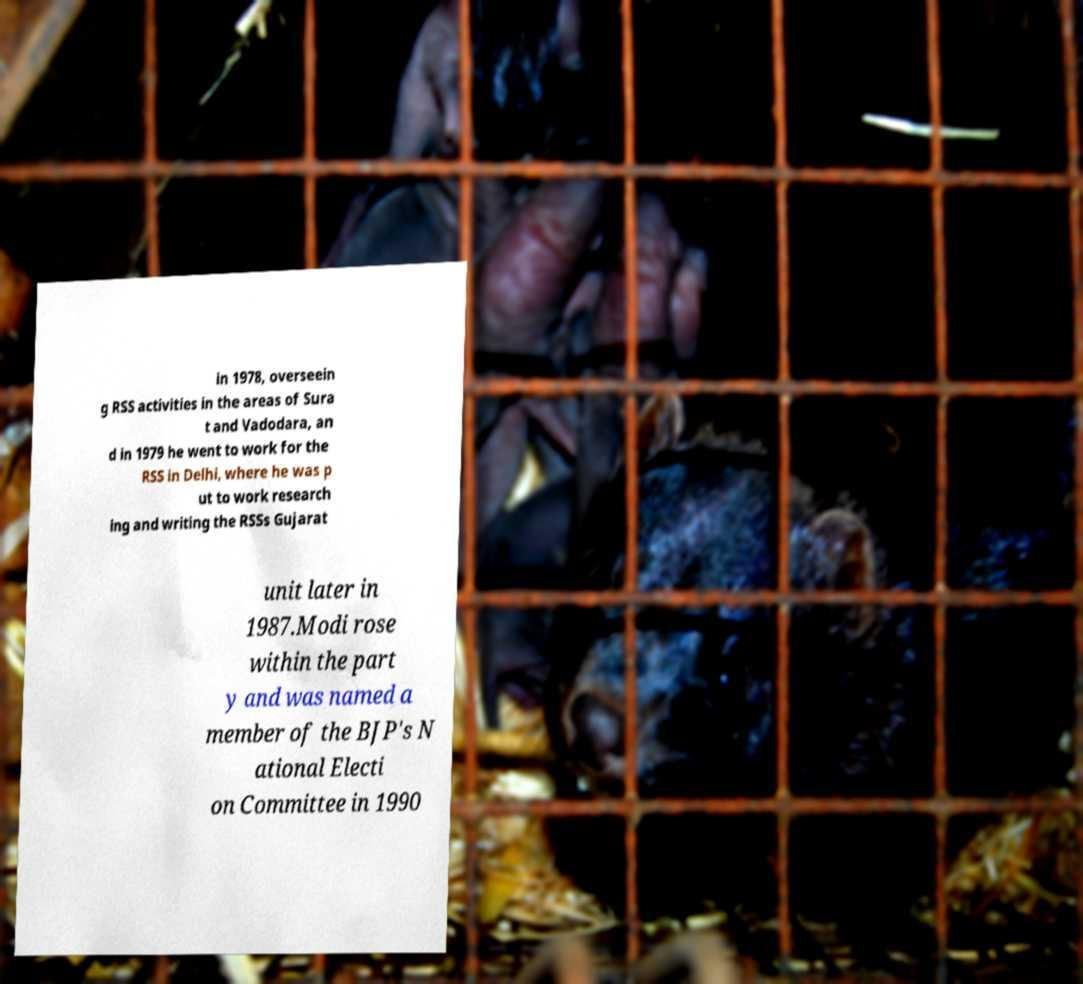Could you assist in decoding the text presented in this image and type it out clearly? in 1978, overseein g RSS activities in the areas of Sura t and Vadodara, an d in 1979 he went to work for the RSS in Delhi, where he was p ut to work research ing and writing the RSSs Gujarat unit later in 1987.Modi rose within the part y and was named a member of the BJP's N ational Electi on Committee in 1990 